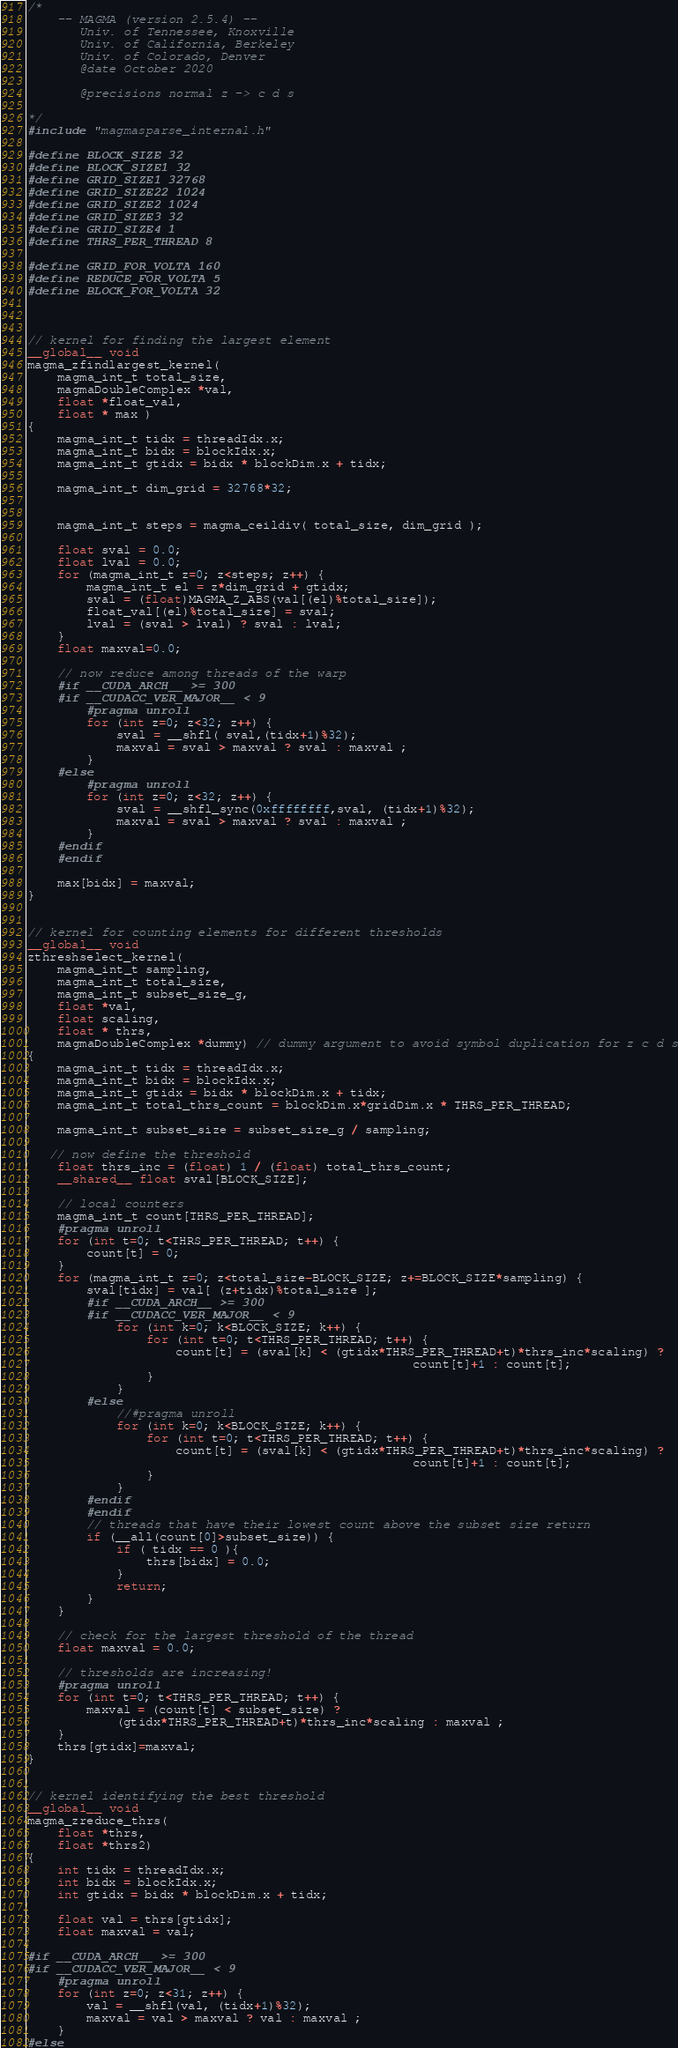Convert code to text. <code><loc_0><loc_0><loc_500><loc_500><_Cuda_>/*
    -- MAGMA (version 2.5.4) --
       Univ. of Tennessee, Knoxville
       Univ. of California, Berkeley
       Univ. of Colorado, Denver
       @date October 2020

       @precisions normal z -> c d s

*/
#include "magmasparse_internal.h"

#define BLOCK_SIZE 32
#define BLOCK_SIZE1 32
#define GRID_SIZE1 32768
#define GRID_SIZE22 1024
#define GRID_SIZE2 1024
#define GRID_SIZE3 32
#define GRID_SIZE4 1
#define THRS_PER_THREAD 8

#define GRID_FOR_VOLTA 160
#define REDUCE_FOR_VOLTA 5
#define BLOCK_FOR_VOLTA 32



// kernel for finding the largest element
__global__ void 
magma_zfindlargest_kernel( 
    magma_int_t total_size,
    magmaDoubleComplex *val,
    float *float_val,
    float * max )
{
    magma_int_t tidx = threadIdx.x;   
    magma_int_t bidx = blockIdx.x;
    magma_int_t gtidx = bidx * blockDim.x + tidx;
    
    magma_int_t dim_grid = 32768*32;
    
    
    magma_int_t steps = magma_ceildiv( total_size, dim_grid );
   
    float sval = 0.0;
    float lval = 0.0;
    for (magma_int_t z=0; z<steps; z++) {
        magma_int_t el = z*dim_grid + gtidx;
        sval = (float)MAGMA_Z_ABS(val[(el)%total_size]);
        float_val[(el)%total_size] = sval;
        lval = (sval > lval) ? sval : lval;
    }
    float maxval=0.0;
    
    // now reduce among threads of the warp
    #if __CUDA_ARCH__ >= 300
    #if __CUDACC_VER_MAJOR__ < 9
        #pragma unroll
        for (int z=0; z<32; z++) {
            sval = __shfl( sval,(tidx+1)%32);
            maxval = sval > maxval ? sval : maxval ;
        }
    #else
        #pragma unroll
        for (int z=0; z<32; z++) {
            sval = __shfl_sync(0xffffffff,sval, (tidx+1)%32);
            maxval = sval > maxval ? sval : maxval ;
        }
    #endif
    #endif
    
    max[bidx] = maxval;
}


// kernel for counting elements for different thresholds
__global__ void 
zthreshselect_kernel( 
    magma_int_t sampling,
    magma_int_t total_size,
    magma_int_t subset_size_g,
    float *val,
    float scaling,
    float * thrs,
    magmaDoubleComplex *dummy) // dummy argument to avoid symbol duplication for z c d s
{
    magma_int_t tidx = threadIdx.x;   
    magma_int_t bidx = blockIdx.x;
    magma_int_t gtidx = bidx * blockDim.x + tidx;
    magma_int_t total_thrs_count = blockDim.x*gridDim.x * THRS_PER_THREAD;
   
    magma_int_t subset_size = subset_size_g / sampling;

   // now define the threshold
    float thrs_inc = (float) 1 / (float) total_thrs_count;
    __shared__ float sval[BLOCK_SIZE];
    
    // local counters
    magma_int_t count[THRS_PER_THREAD];
    #pragma unroll
    for (int t=0; t<THRS_PER_THREAD; t++) {
        count[t] = 0;
    }
    for (magma_int_t z=0; z<total_size-BLOCK_SIZE; z+=BLOCK_SIZE*sampling) {
        sval[tidx] = val[ (z+tidx)%total_size ];
        #if __CUDA_ARCH__ >= 300
        #if __CUDACC_VER_MAJOR__ < 9
            for (int k=0; k<BLOCK_SIZE; k++) {
                for (int t=0; t<THRS_PER_THREAD; t++) {
                    count[t] = (sval[k] < (gtidx*THRS_PER_THREAD+t)*thrs_inc*scaling) ?
                                                    count[t]+1 : count[t];
                }
            }       
        #else
            //#pragma unroll
            for (int k=0; k<BLOCK_SIZE; k++) {
                for (int t=0; t<THRS_PER_THREAD; t++) {
                    count[t] = (sval[k] < (gtidx*THRS_PER_THREAD+t)*thrs_inc*scaling) ? 
                                                    count[t]+1 : count[t];
                }
            }
        #endif
        #endif
        // threads that have their lowest count above the subset size return
        if (__all(count[0]>subset_size)) { 
            if ( tidx == 0 ){
                thrs[bidx] = 0.0;
            }
            return;
        }
    }
    
    // check for the largest threshold of the thread
    float maxval = 0.0;
    
    // thresholds are increasing!
    #pragma unroll
    for (int t=0; t<THRS_PER_THREAD; t++) {
        maxval = (count[t] < subset_size) ? 
            (gtidx*THRS_PER_THREAD+t)*thrs_inc*scaling : maxval ;
    }
    thrs[gtidx]=maxval;
}


// kernel identifying the best threshold
__global__ void
magma_zreduce_thrs( 
    float *thrs,
    float *thrs2)
{
    int tidx = threadIdx.x;   
    int bidx = blockIdx.x;
    int gtidx = bidx * blockDim.x + tidx;
    
    float val = thrs[gtidx];
    float maxval = val;
    
#if __CUDA_ARCH__ >= 300
#if __CUDACC_VER_MAJOR__ < 9
    #pragma unroll
    for (int z=0; z<31; z++) {
        val = __shfl(val, (tidx+1)%32);
        maxval = val > maxval ? val : maxval ;
    }
#else</code> 